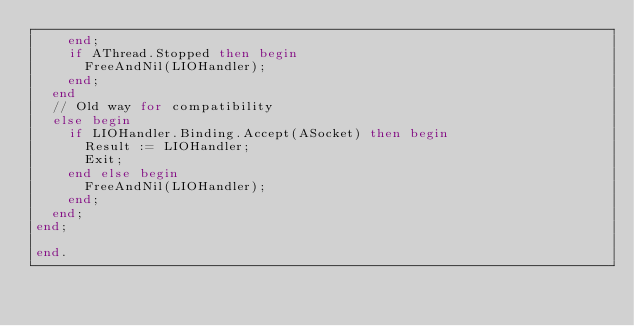Convert code to text. <code><loc_0><loc_0><loc_500><loc_500><_Pascal_>    end;
    if AThread.Stopped then begin
      FreeAndNil(LIOHandler);
    end;
  end
  // Old way for compatibility
  else begin
    if LIOHandler.Binding.Accept(ASocket) then begin
      Result := LIOHandler;
      Exit;
    end else begin
      FreeAndNil(LIOHandler);
    end;
  end;
end;

end.
 
</code> 